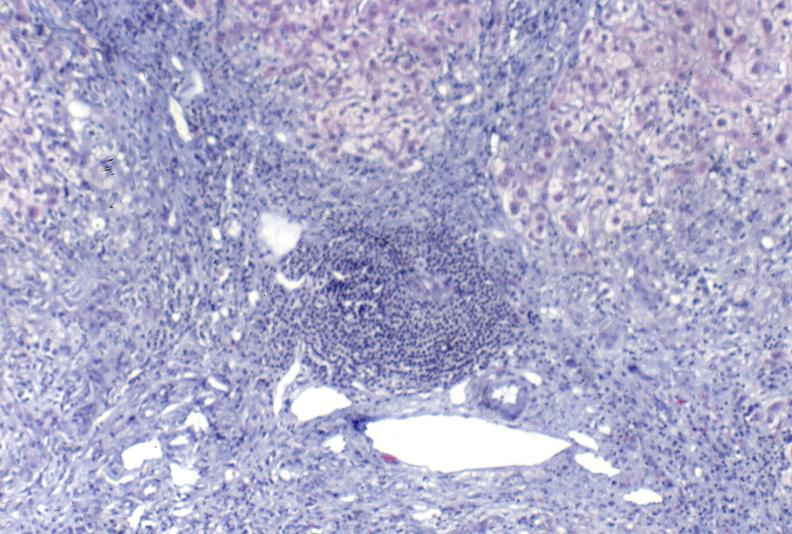what is present?
Answer the question using a single word or phrase. Liver 